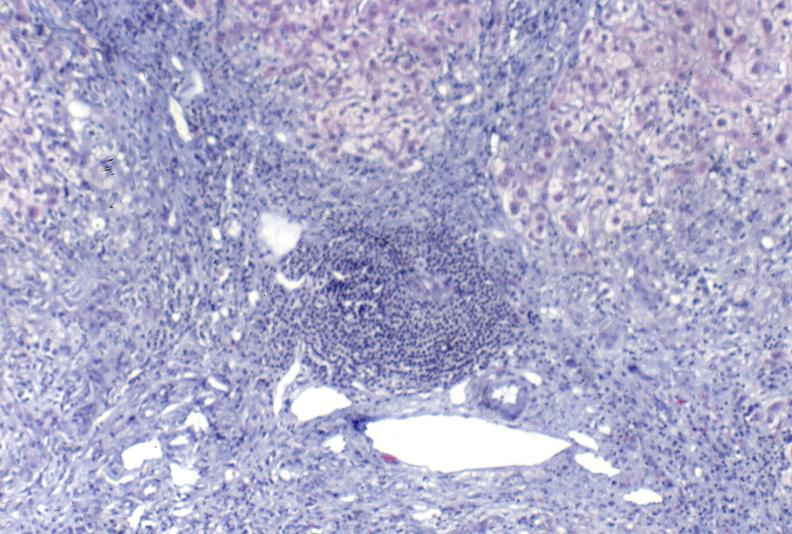what is present?
Answer the question using a single word or phrase. Liver 